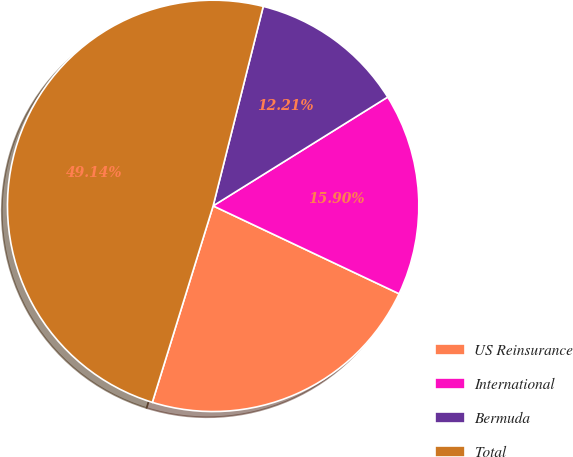Convert chart. <chart><loc_0><loc_0><loc_500><loc_500><pie_chart><fcel>US Reinsurance<fcel>International<fcel>Bermuda<fcel>Total<nl><fcel>22.75%<fcel>15.9%<fcel>12.21%<fcel>49.14%<nl></chart> 